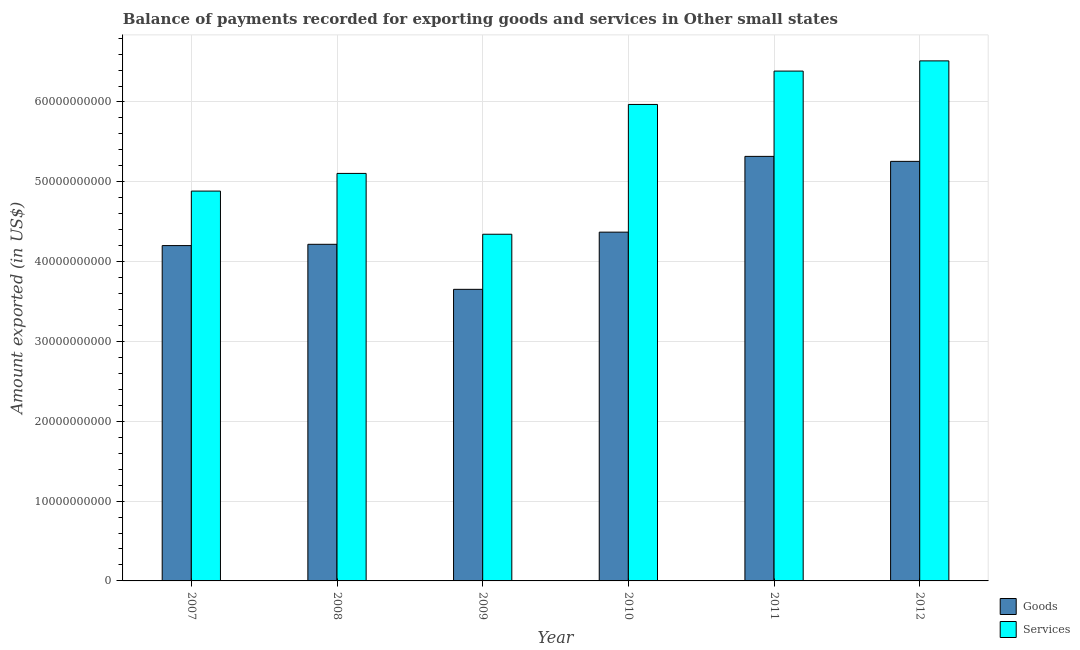How many groups of bars are there?
Make the answer very short. 6. Are the number of bars per tick equal to the number of legend labels?
Your response must be concise. Yes. What is the label of the 6th group of bars from the left?
Provide a short and direct response. 2012. What is the amount of goods exported in 2010?
Ensure brevity in your answer.  4.37e+1. Across all years, what is the maximum amount of goods exported?
Provide a succinct answer. 5.32e+1. Across all years, what is the minimum amount of services exported?
Provide a succinct answer. 4.34e+1. What is the total amount of goods exported in the graph?
Offer a terse response. 2.70e+11. What is the difference between the amount of goods exported in 2007 and that in 2010?
Your answer should be very brief. -1.68e+09. What is the difference between the amount of services exported in 2012 and the amount of goods exported in 2007?
Keep it short and to the point. 1.63e+1. What is the average amount of services exported per year?
Make the answer very short. 5.53e+1. In how many years, is the amount of services exported greater than 14000000000 US$?
Provide a succinct answer. 6. What is the ratio of the amount of services exported in 2007 to that in 2010?
Ensure brevity in your answer.  0.82. What is the difference between the highest and the second highest amount of services exported?
Give a very brief answer. 1.28e+09. What is the difference between the highest and the lowest amount of services exported?
Give a very brief answer. 2.17e+1. In how many years, is the amount of goods exported greater than the average amount of goods exported taken over all years?
Make the answer very short. 2. Is the sum of the amount of services exported in 2007 and 2012 greater than the maximum amount of goods exported across all years?
Keep it short and to the point. Yes. What does the 1st bar from the left in 2010 represents?
Provide a succinct answer. Goods. What does the 2nd bar from the right in 2007 represents?
Offer a very short reply. Goods. Are all the bars in the graph horizontal?
Your answer should be very brief. No. What is the difference between two consecutive major ticks on the Y-axis?
Ensure brevity in your answer.  1.00e+1. Does the graph contain any zero values?
Offer a terse response. No. Does the graph contain grids?
Provide a short and direct response. Yes. How many legend labels are there?
Provide a short and direct response. 2. How are the legend labels stacked?
Make the answer very short. Vertical. What is the title of the graph?
Keep it short and to the point. Balance of payments recorded for exporting goods and services in Other small states. What is the label or title of the Y-axis?
Make the answer very short. Amount exported (in US$). What is the Amount exported (in US$) in Goods in 2007?
Offer a very short reply. 4.20e+1. What is the Amount exported (in US$) of Services in 2007?
Ensure brevity in your answer.  4.88e+1. What is the Amount exported (in US$) in Goods in 2008?
Your answer should be very brief. 4.22e+1. What is the Amount exported (in US$) of Services in 2008?
Offer a terse response. 5.11e+1. What is the Amount exported (in US$) of Goods in 2009?
Offer a terse response. 3.65e+1. What is the Amount exported (in US$) of Services in 2009?
Provide a succinct answer. 4.34e+1. What is the Amount exported (in US$) in Goods in 2010?
Offer a terse response. 4.37e+1. What is the Amount exported (in US$) in Services in 2010?
Give a very brief answer. 5.97e+1. What is the Amount exported (in US$) in Goods in 2011?
Provide a short and direct response. 5.32e+1. What is the Amount exported (in US$) of Services in 2011?
Make the answer very short. 6.39e+1. What is the Amount exported (in US$) in Goods in 2012?
Provide a short and direct response. 5.26e+1. What is the Amount exported (in US$) of Services in 2012?
Keep it short and to the point. 6.52e+1. Across all years, what is the maximum Amount exported (in US$) in Goods?
Give a very brief answer. 5.32e+1. Across all years, what is the maximum Amount exported (in US$) of Services?
Provide a succinct answer. 6.52e+1. Across all years, what is the minimum Amount exported (in US$) of Goods?
Keep it short and to the point. 3.65e+1. Across all years, what is the minimum Amount exported (in US$) of Services?
Offer a terse response. 4.34e+1. What is the total Amount exported (in US$) in Goods in the graph?
Offer a terse response. 2.70e+11. What is the total Amount exported (in US$) in Services in the graph?
Give a very brief answer. 3.32e+11. What is the difference between the Amount exported (in US$) of Goods in 2007 and that in 2008?
Offer a very short reply. -1.59e+08. What is the difference between the Amount exported (in US$) of Services in 2007 and that in 2008?
Provide a succinct answer. -2.21e+09. What is the difference between the Amount exported (in US$) in Goods in 2007 and that in 2009?
Your answer should be very brief. 5.48e+09. What is the difference between the Amount exported (in US$) in Services in 2007 and that in 2009?
Ensure brevity in your answer.  5.41e+09. What is the difference between the Amount exported (in US$) in Goods in 2007 and that in 2010?
Your answer should be very brief. -1.68e+09. What is the difference between the Amount exported (in US$) of Services in 2007 and that in 2010?
Provide a succinct answer. -1.09e+1. What is the difference between the Amount exported (in US$) in Goods in 2007 and that in 2011?
Your answer should be compact. -1.12e+1. What is the difference between the Amount exported (in US$) in Services in 2007 and that in 2011?
Keep it short and to the point. -1.50e+1. What is the difference between the Amount exported (in US$) of Goods in 2007 and that in 2012?
Keep it short and to the point. -1.06e+1. What is the difference between the Amount exported (in US$) in Services in 2007 and that in 2012?
Keep it short and to the point. -1.63e+1. What is the difference between the Amount exported (in US$) of Goods in 2008 and that in 2009?
Provide a short and direct response. 5.64e+09. What is the difference between the Amount exported (in US$) in Services in 2008 and that in 2009?
Your response must be concise. 7.62e+09. What is the difference between the Amount exported (in US$) of Goods in 2008 and that in 2010?
Offer a terse response. -1.52e+09. What is the difference between the Amount exported (in US$) in Services in 2008 and that in 2010?
Provide a short and direct response. -8.64e+09. What is the difference between the Amount exported (in US$) in Goods in 2008 and that in 2011?
Offer a very short reply. -1.10e+1. What is the difference between the Amount exported (in US$) in Services in 2008 and that in 2011?
Ensure brevity in your answer.  -1.28e+1. What is the difference between the Amount exported (in US$) in Goods in 2008 and that in 2012?
Provide a succinct answer. -1.04e+1. What is the difference between the Amount exported (in US$) of Services in 2008 and that in 2012?
Your response must be concise. -1.41e+1. What is the difference between the Amount exported (in US$) in Goods in 2009 and that in 2010?
Your answer should be very brief. -7.16e+09. What is the difference between the Amount exported (in US$) in Services in 2009 and that in 2010?
Your response must be concise. -1.63e+1. What is the difference between the Amount exported (in US$) in Goods in 2009 and that in 2011?
Your answer should be compact. -1.67e+1. What is the difference between the Amount exported (in US$) of Services in 2009 and that in 2011?
Your response must be concise. -2.04e+1. What is the difference between the Amount exported (in US$) in Goods in 2009 and that in 2012?
Your answer should be very brief. -1.60e+1. What is the difference between the Amount exported (in US$) in Services in 2009 and that in 2012?
Your response must be concise. -2.17e+1. What is the difference between the Amount exported (in US$) in Goods in 2010 and that in 2011?
Offer a very short reply. -9.49e+09. What is the difference between the Amount exported (in US$) of Services in 2010 and that in 2011?
Provide a succinct answer. -4.18e+09. What is the difference between the Amount exported (in US$) of Goods in 2010 and that in 2012?
Your answer should be very brief. -8.87e+09. What is the difference between the Amount exported (in US$) in Services in 2010 and that in 2012?
Your answer should be compact. -5.46e+09. What is the difference between the Amount exported (in US$) of Goods in 2011 and that in 2012?
Ensure brevity in your answer.  6.23e+08. What is the difference between the Amount exported (in US$) of Services in 2011 and that in 2012?
Ensure brevity in your answer.  -1.28e+09. What is the difference between the Amount exported (in US$) in Goods in 2007 and the Amount exported (in US$) in Services in 2008?
Ensure brevity in your answer.  -9.04e+09. What is the difference between the Amount exported (in US$) of Goods in 2007 and the Amount exported (in US$) of Services in 2009?
Provide a short and direct response. -1.42e+09. What is the difference between the Amount exported (in US$) in Goods in 2007 and the Amount exported (in US$) in Services in 2010?
Provide a short and direct response. -1.77e+1. What is the difference between the Amount exported (in US$) of Goods in 2007 and the Amount exported (in US$) of Services in 2011?
Offer a very short reply. -2.19e+1. What is the difference between the Amount exported (in US$) in Goods in 2007 and the Amount exported (in US$) in Services in 2012?
Provide a succinct answer. -2.31e+1. What is the difference between the Amount exported (in US$) in Goods in 2008 and the Amount exported (in US$) in Services in 2009?
Keep it short and to the point. -1.26e+09. What is the difference between the Amount exported (in US$) in Goods in 2008 and the Amount exported (in US$) in Services in 2010?
Give a very brief answer. -1.75e+1. What is the difference between the Amount exported (in US$) of Goods in 2008 and the Amount exported (in US$) of Services in 2011?
Make the answer very short. -2.17e+1. What is the difference between the Amount exported (in US$) of Goods in 2008 and the Amount exported (in US$) of Services in 2012?
Make the answer very short. -2.30e+1. What is the difference between the Amount exported (in US$) in Goods in 2009 and the Amount exported (in US$) in Services in 2010?
Provide a short and direct response. -2.32e+1. What is the difference between the Amount exported (in US$) of Goods in 2009 and the Amount exported (in US$) of Services in 2011?
Give a very brief answer. -2.73e+1. What is the difference between the Amount exported (in US$) of Goods in 2009 and the Amount exported (in US$) of Services in 2012?
Give a very brief answer. -2.86e+1. What is the difference between the Amount exported (in US$) of Goods in 2010 and the Amount exported (in US$) of Services in 2011?
Provide a succinct answer. -2.02e+1. What is the difference between the Amount exported (in US$) in Goods in 2010 and the Amount exported (in US$) in Services in 2012?
Provide a short and direct response. -2.15e+1. What is the difference between the Amount exported (in US$) in Goods in 2011 and the Amount exported (in US$) in Services in 2012?
Your answer should be very brief. -1.20e+1. What is the average Amount exported (in US$) of Goods per year?
Your answer should be very brief. 4.50e+1. What is the average Amount exported (in US$) in Services per year?
Offer a very short reply. 5.53e+1. In the year 2007, what is the difference between the Amount exported (in US$) of Goods and Amount exported (in US$) of Services?
Keep it short and to the point. -6.83e+09. In the year 2008, what is the difference between the Amount exported (in US$) of Goods and Amount exported (in US$) of Services?
Provide a succinct answer. -8.88e+09. In the year 2009, what is the difference between the Amount exported (in US$) of Goods and Amount exported (in US$) of Services?
Your response must be concise. -6.90e+09. In the year 2010, what is the difference between the Amount exported (in US$) of Goods and Amount exported (in US$) of Services?
Offer a very short reply. -1.60e+1. In the year 2011, what is the difference between the Amount exported (in US$) of Goods and Amount exported (in US$) of Services?
Keep it short and to the point. -1.07e+1. In the year 2012, what is the difference between the Amount exported (in US$) of Goods and Amount exported (in US$) of Services?
Your answer should be very brief. -1.26e+1. What is the ratio of the Amount exported (in US$) of Services in 2007 to that in 2008?
Your response must be concise. 0.96. What is the ratio of the Amount exported (in US$) in Goods in 2007 to that in 2009?
Ensure brevity in your answer.  1.15. What is the ratio of the Amount exported (in US$) of Services in 2007 to that in 2009?
Provide a short and direct response. 1.12. What is the ratio of the Amount exported (in US$) in Goods in 2007 to that in 2010?
Your response must be concise. 0.96. What is the ratio of the Amount exported (in US$) of Services in 2007 to that in 2010?
Offer a terse response. 0.82. What is the ratio of the Amount exported (in US$) of Goods in 2007 to that in 2011?
Provide a short and direct response. 0.79. What is the ratio of the Amount exported (in US$) in Services in 2007 to that in 2011?
Your response must be concise. 0.76. What is the ratio of the Amount exported (in US$) in Goods in 2007 to that in 2012?
Keep it short and to the point. 0.8. What is the ratio of the Amount exported (in US$) of Services in 2007 to that in 2012?
Make the answer very short. 0.75. What is the ratio of the Amount exported (in US$) in Goods in 2008 to that in 2009?
Make the answer very short. 1.15. What is the ratio of the Amount exported (in US$) in Services in 2008 to that in 2009?
Provide a succinct answer. 1.18. What is the ratio of the Amount exported (in US$) of Goods in 2008 to that in 2010?
Make the answer very short. 0.97. What is the ratio of the Amount exported (in US$) in Services in 2008 to that in 2010?
Ensure brevity in your answer.  0.86. What is the ratio of the Amount exported (in US$) in Goods in 2008 to that in 2011?
Your response must be concise. 0.79. What is the ratio of the Amount exported (in US$) in Services in 2008 to that in 2011?
Offer a terse response. 0.8. What is the ratio of the Amount exported (in US$) of Goods in 2008 to that in 2012?
Make the answer very short. 0.8. What is the ratio of the Amount exported (in US$) of Services in 2008 to that in 2012?
Your answer should be very brief. 0.78. What is the ratio of the Amount exported (in US$) of Goods in 2009 to that in 2010?
Your response must be concise. 0.84. What is the ratio of the Amount exported (in US$) of Services in 2009 to that in 2010?
Offer a very short reply. 0.73. What is the ratio of the Amount exported (in US$) in Goods in 2009 to that in 2011?
Keep it short and to the point. 0.69. What is the ratio of the Amount exported (in US$) in Services in 2009 to that in 2011?
Offer a very short reply. 0.68. What is the ratio of the Amount exported (in US$) of Goods in 2009 to that in 2012?
Your answer should be very brief. 0.69. What is the ratio of the Amount exported (in US$) in Services in 2009 to that in 2012?
Keep it short and to the point. 0.67. What is the ratio of the Amount exported (in US$) in Goods in 2010 to that in 2011?
Your answer should be compact. 0.82. What is the ratio of the Amount exported (in US$) of Services in 2010 to that in 2011?
Your response must be concise. 0.93. What is the ratio of the Amount exported (in US$) in Goods in 2010 to that in 2012?
Offer a very short reply. 0.83. What is the ratio of the Amount exported (in US$) of Services in 2010 to that in 2012?
Offer a very short reply. 0.92. What is the ratio of the Amount exported (in US$) of Goods in 2011 to that in 2012?
Offer a very short reply. 1.01. What is the ratio of the Amount exported (in US$) in Services in 2011 to that in 2012?
Keep it short and to the point. 0.98. What is the difference between the highest and the second highest Amount exported (in US$) in Goods?
Your answer should be very brief. 6.23e+08. What is the difference between the highest and the second highest Amount exported (in US$) in Services?
Provide a short and direct response. 1.28e+09. What is the difference between the highest and the lowest Amount exported (in US$) of Goods?
Give a very brief answer. 1.67e+1. What is the difference between the highest and the lowest Amount exported (in US$) of Services?
Your response must be concise. 2.17e+1. 